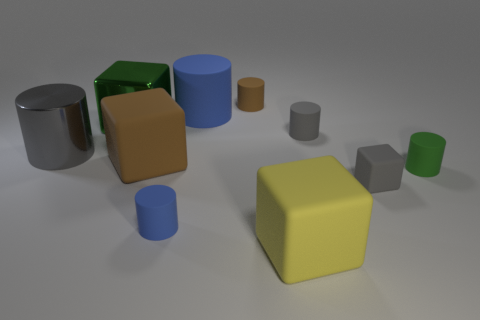What color is the metal cube that is the same size as the yellow thing?
Your response must be concise. Green. The tiny object that is both in front of the tiny green thing and on the right side of the small blue cylinder is made of what material?
Make the answer very short. Rubber. How many shiny things are either tiny red spheres or small gray objects?
Ensure brevity in your answer.  0. What is the shape of the large brown thing that is made of the same material as the small blue object?
Your response must be concise. Cube. What number of big objects are both on the left side of the large green cube and to the right of the small blue thing?
Give a very brief answer. 0. Is there any other thing that has the same shape as the gray metal object?
Offer a very short reply. Yes. There is a blue object behind the large gray object; what size is it?
Your answer should be compact. Large. What number of other objects are there of the same color as the tiny cube?
Your response must be concise. 2. What material is the gray cylinder that is to the left of the big metal object behind the small gray rubber cylinder made of?
Give a very brief answer. Metal. There is a block that is on the right side of the large yellow rubber cube; does it have the same color as the large metal cylinder?
Provide a succinct answer. Yes. 